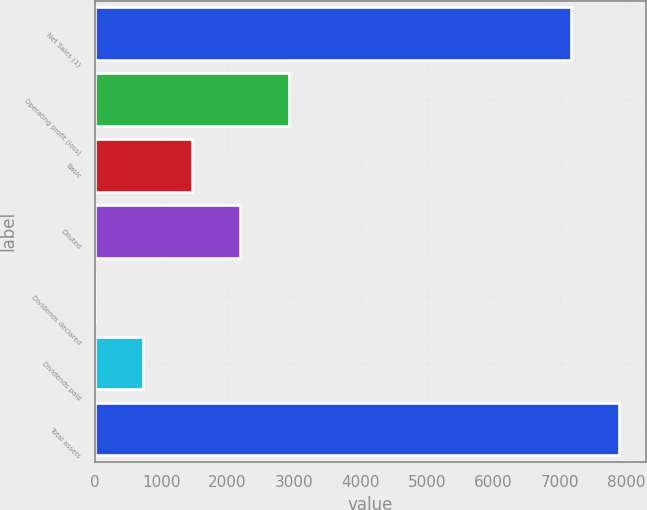<chart> <loc_0><loc_0><loc_500><loc_500><bar_chart><fcel>Net Sales (1)<fcel>Operating profit (loss)<fcel>Basic<fcel>Diluted<fcel>Dividends declared<fcel>Dividends paid<fcel>Total assets<nl><fcel>7170<fcel>2918.98<fcel>1459.64<fcel>2189.31<fcel>0.3<fcel>729.97<fcel>7899.67<nl></chart> 